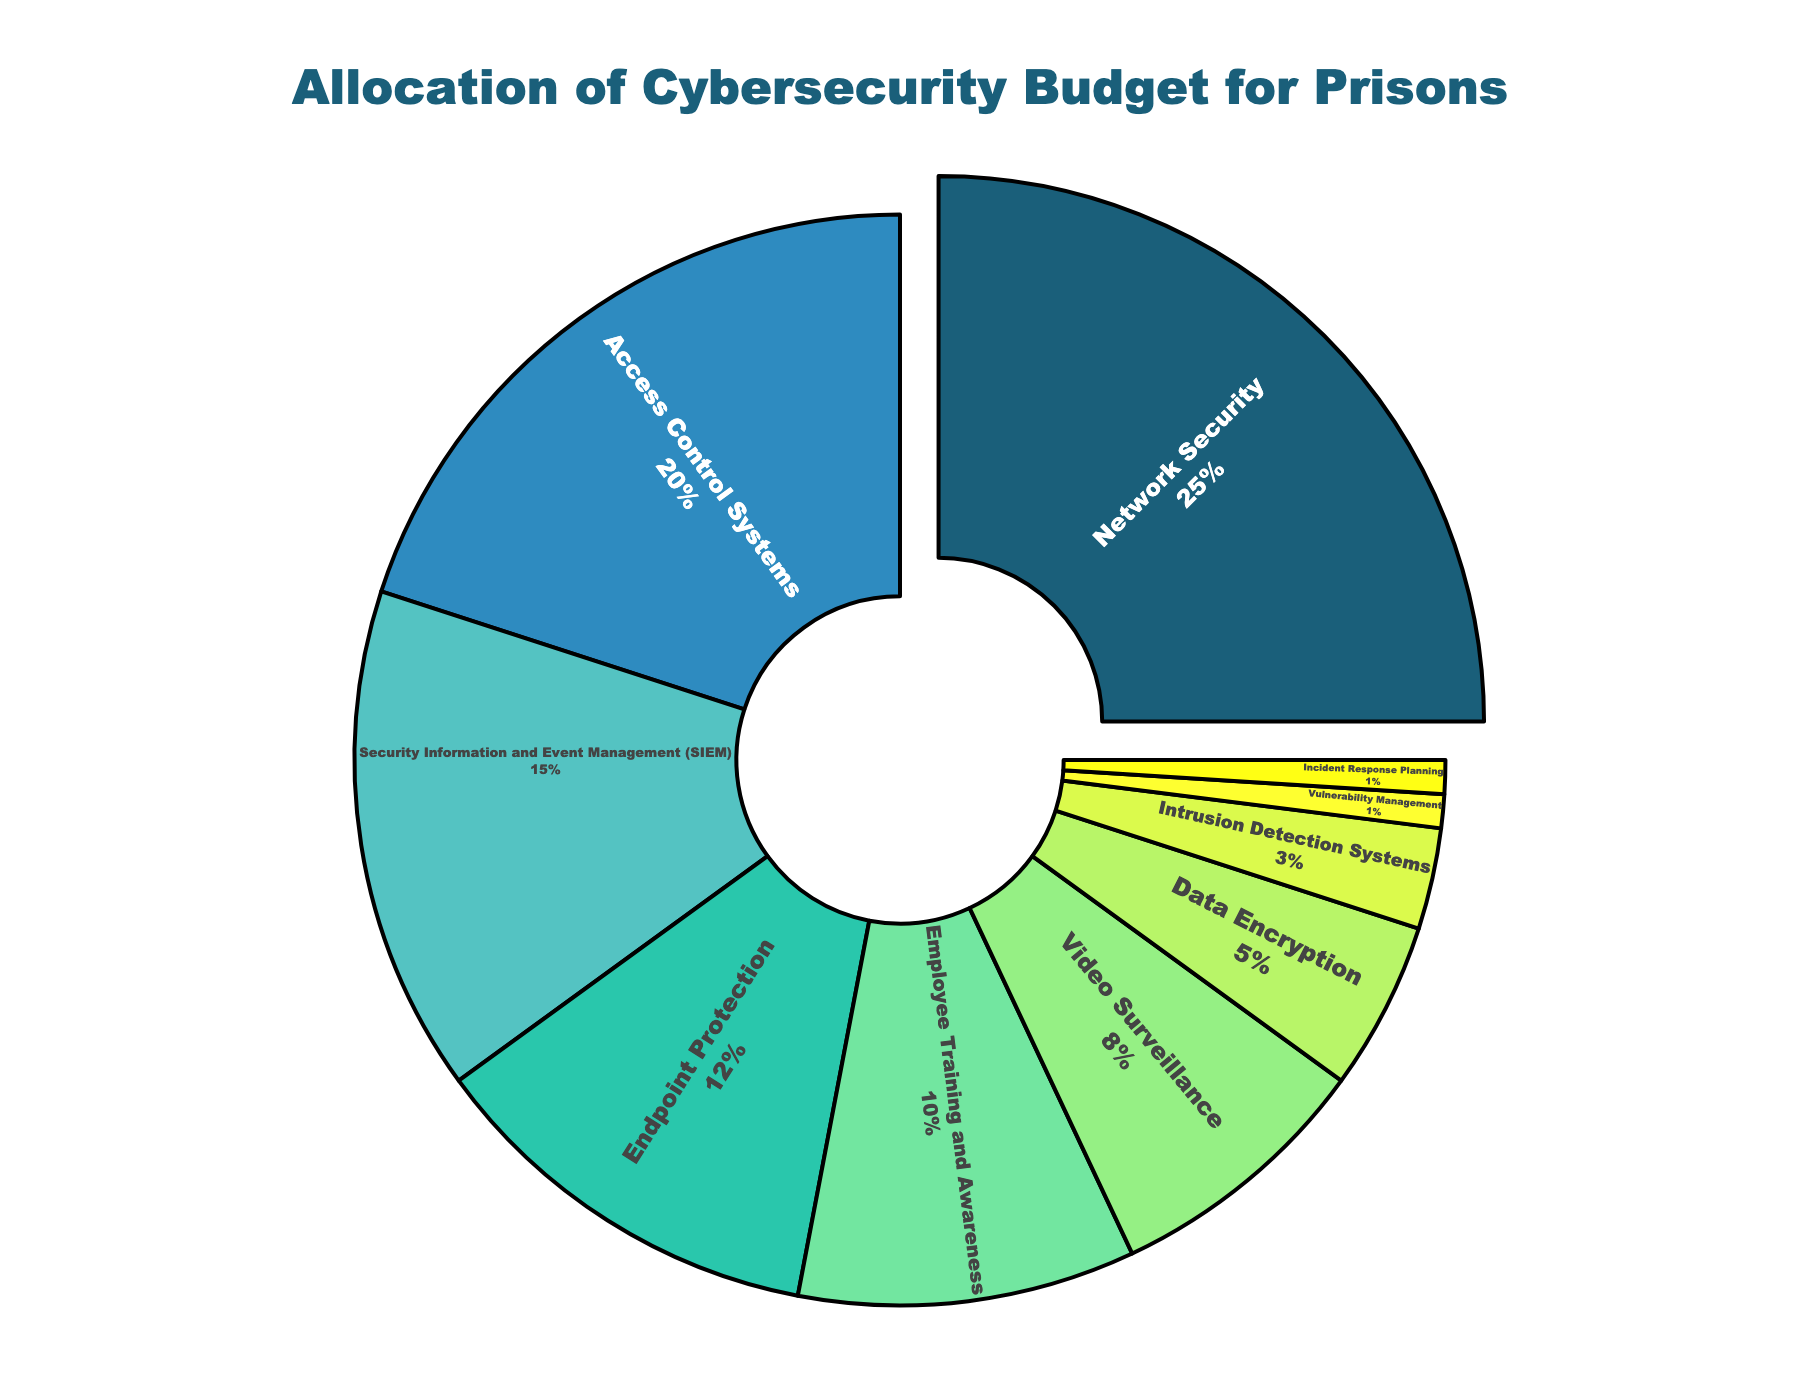Which category has the highest allocation in the cybersecurity budget for prisons? The largest slice of the pie chart, indicated by a slight pull-out effect, has a label of "Network Security" with a percentage of 25%.
Answer: Network Security Which two categories combined account for the largest portion of the cybersecurity budget? Summing the percentages of the two largest categories: Network Security (25%) + Access Control Systems (20%) = 45%, which is the highest combined percentage.
Answer: Network Security and Access Control Systems Which categories receive less than 10% of the cybersecurity budget? The pie chart labels that show less than 10% are: Video Surveillance (8%), Data Encryption (5%), Intrusion Detection Systems (3%), Vulnerability Management (1%), and Incident Response Planning (1%).
Answer: Video Surveillance, Data Encryption, Intrusion Detection Systems, Vulnerability Management, Incident Response Planning How much more percentage is allocated to Employee Training and Awareness compared to Incident Response Planning? Employee Training and Awareness has 10%, and Incident Response Planning has 1%. Subtracting these values: 10% - 1% = 9%.
Answer: 9% What proportion of the total budget is allocated to security measures not exceeding 12% individually? Summing up categories with ≤ 12%: Endpoint Protection (12%) + Employee Training and Awareness (10%) + Video Surveillance (8%) + Data Encryption (5%) + Intrusion Detection Systems (3%) + Vulnerability Management (1%) + Incident Response Planning (1%) = 40%.
Answer: 40% Which category with an allocation less than 15% is nearest to this threshold? The category just below 15% is Endpoint Protection, which is allocated 12%.
Answer: Endpoint Protection Considering only the top three categories, what percentage of the total budget is allocated to these measures combined? Summing the top three categories: Network Security (25%) + Access Control Systems (20%) + Security Information and Event Management (SIEM) (15%) = 60%.
Answer: 60% How does the allocation for Video Surveillance compare to that of Data Encryption? Video Surveillance has an allocation of 8%, while Data Encryption has 5%. Comparing these: 8% is greater than 5%.
Answer: Greater than Which measure requires double the budget of Data Encryption? Double the percentage of Data Encryption (5%) is 10%. The measure with exactly 10% is Employee Training and Awareness.
Answer: Employee Training and Awareness What percentage of the budget is allocated to measures directly related to incident handling (Incident Response Planning and Intrusion Detection Systems)? Summing up Incident Response Planning (1%) and Intrusion Detection Systems (3%): 1% + 3% = 4%.
Answer: 4% 